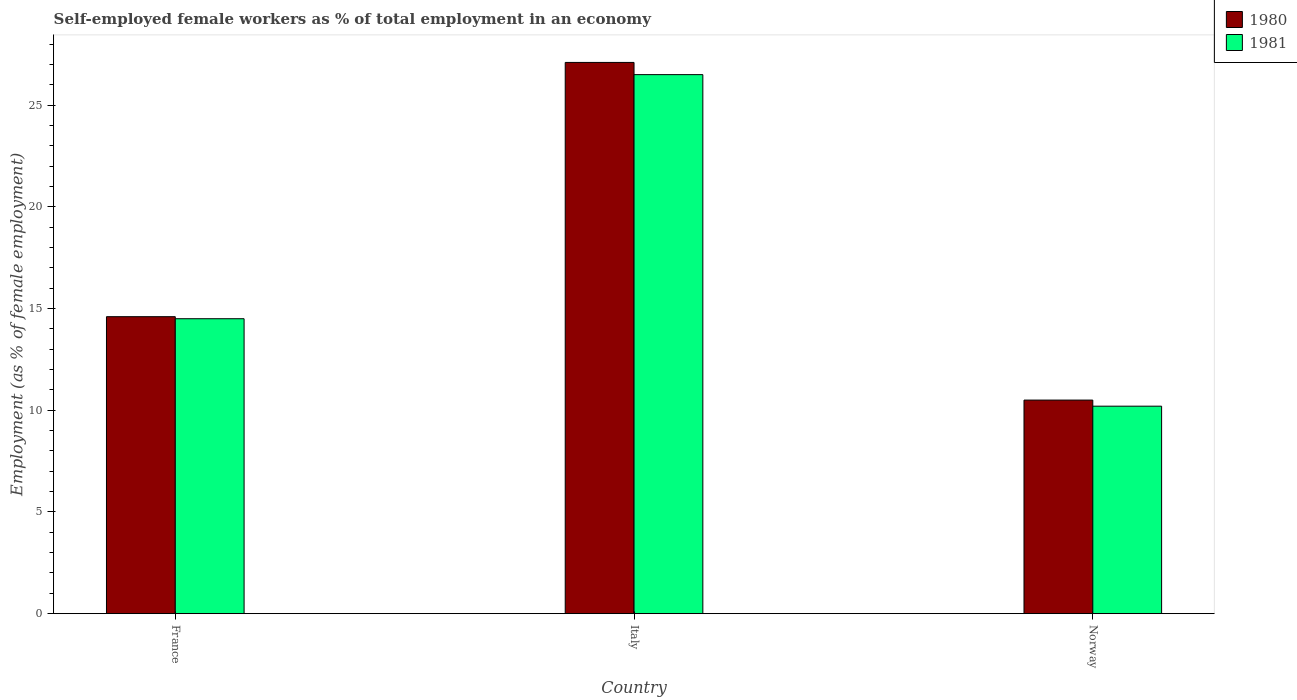How many groups of bars are there?
Offer a very short reply. 3. Are the number of bars per tick equal to the number of legend labels?
Provide a short and direct response. Yes. How many bars are there on the 1st tick from the left?
Provide a succinct answer. 2. What is the percentage of self-employed female workers in 1980 in Italy?
Provide a succinct answer. 27.1. Across all countries, what is the maximum percentage of self-employed female workers in 1980?
Offer a terse response. 27.1. Across all countries, what is the minimum percentage of self-employed female workers in 1980?
Your answer should be very brief. 10.5. In which country was the percentage of self-employed female workers in 1980 maximum?
Offer a very short reply. Italy. In which country was the percentage of self-employed female workers in 1980 minimum?
Your answer should be compact. Norway. What is the total percentage of self-employed female workers in 1981 in the graph?
Your answer should be very brief. 51.2. What is the difference between the percentage of self-employed female workers in 1980 in Italy and that in Norway?
Provide a short and direct response. 16.6. What is the difference between the percentage of self-employed female workers in 1980 in France and the percentage of self-employed female workers in 1981 in Norway?
Make the answer very short. 4.4. What is the average percentage of self-employed female workers in 1981 per country?
Provide a short and direct response. 17.07. What is the difference between the percentage of self-employed female workers of/in 1981 and percentage of self-employed female workers of/in 1980 in Italy?
Offer a terse response. -0.6. In how many countries, is the percentage of self-employed female workers in 1981 greater than 22 %?
Your answer should be compact. 1. What is the ratio of the percentage of self-employed female workers in 1981 in France to that in Norway?
Your answer should be compact. 1.42. Is the percentage of self-employed female workers in 1981 in France less than that in Italy?
Ensure brevity in your answer.  Yes. Is the difference between the percentage of self-employed female workers in 1981 in Italy and Norway greater than the difference between the percentage of self-employed female workers in 1980 in Italy and Norway?
Ensure brevity in your answer.  No. What is the difference between the highest and the second highest percentage of self-employed female workers in 1980?
Provide a short and direct response. -16.6. What is the difference between the highest and the lowest percentage of self-employed female workers in 1981?
Provide a succinct answer. 16.3. Is the sum of the percentage of self-employed female workers in 1981 in France and Italy greater than the maximum percentage of self-employed female workers in 1980 across all countries?
Keep it short and to the point. Yes. What does the 2nd bar from the left in Norway represents?
Offer a very short reply. 1981. How many bars are there?
Keep it short and to the point. 6. Are the values on the major ticks of Y-axis written in scientific E-notation?
Your response must be concise. No. Does the graph contain grids?
Ensure brevity in your answer.  No. Where does the legend appear in the graph?
Provide a short and direct response. Top right. How are the legend labels stacked?
Make the answer very short. Vertical. What is the title of the graph?
Make the answer very short. Self-employed female workers as % of total employment in an economy. What is the label or title of the X-axis?
Your answer should be very brief. Country. What is the label or title of the Y-axis?
Offer a terse response. Employment (as % of female employment). What is the Employment (as % of female employment) of 1980 in France?
Your answer should be very brief. 14.6. What is the Employment (as % of female employment) in 1980 in Italy?
Ensure brevity in your answer.  27.1. What is the Employment (as % of female employment) of 1981 in Italy?
Make the answer very short. 26.5. What is the Employment (as % of female employment) of 1981 in Norway?
Provide a short and direct response. 10.2. Across all countries, what is the maximum Employment (as % of female employment) in 1980?
Offer a very short reply. 27.1. Across all countries, what is the maximum Employment (as % of female employment) in 1981?
Your answer should be compact. 26.5. Across all countries, what is the minimum Employment (as % of female employment) in 1980?
Keep it short and to the point. 10.5. Across all countries, what is the minimum Employment (as % of female employment) of 1981?
Offer a terse response. 10.2. What is the total Employment (as % of female employment) of 1980 in the graph?
Keep it short and to the point. 52.2. What is the total Employment (as % of female employment) of 1981 in the graph?
Your answer should be very brief. 51.2. What is the difference between the Employment (as % of female employment) in 1981 in France and that in Norway?
Ensure brevity in your answer.  4.3. What is the difference between the Employment (as % of female employment) in 1980 in Italy and that in Norway?
Offer a very short reply. 16.6. What is the difference between the Employment (as % of female employment) of 1981 in Italy and that in Norway?
Ensure brevity in your answer.  16.3. What is the difference between the Employment (as % of female employment) of 1980 in France and the Employment (as % of female employment) of 1981 in Norway?
Provide a succinct answer. 4.4. What is the average Employment (as % of female employment) in 1980 per country?
Your answer should be compact. 17.4. What is the average Employment (as % of female employment) of 1981 per country?
Keep it short and to the point. 17.07. What is the difference between the Employment (as % of female employment) of 1980 and Employment (as % of female employment) of 1981 in Italy?
Give a very brief answer. 0.6. What is the ratio of the Employment (as % of female employment) in 1980 in France to that in Italy?
Make the answer very short. 0.54. What is the ratio of the Employment (as % of female employment) in 1981 in France to that in Italy?
Make the answer very short. 0.55. What is the ratio of the Employment (as % of female employment) in 1980 in France to that in Norway?
Offer a terse response. 1.39. What is the ratio of the Employment (as % of female employment) in 1981 in France to that in Norway?
Provide a short and direct response. 1.42. What is the ratio of the Employment (as % of female employment) of 1980 in Italy to that in Norway?
Your response must be concise. 2.58. What is the ratio of the Employment (as % of female employment) of 1981 in Italy to that in Norway?
Provide a short and direct response. 2.6. What is the difference between the highest and the lowest Employment (as % of female employment) of 1980?
Provide a short and direct response. 16.6. 